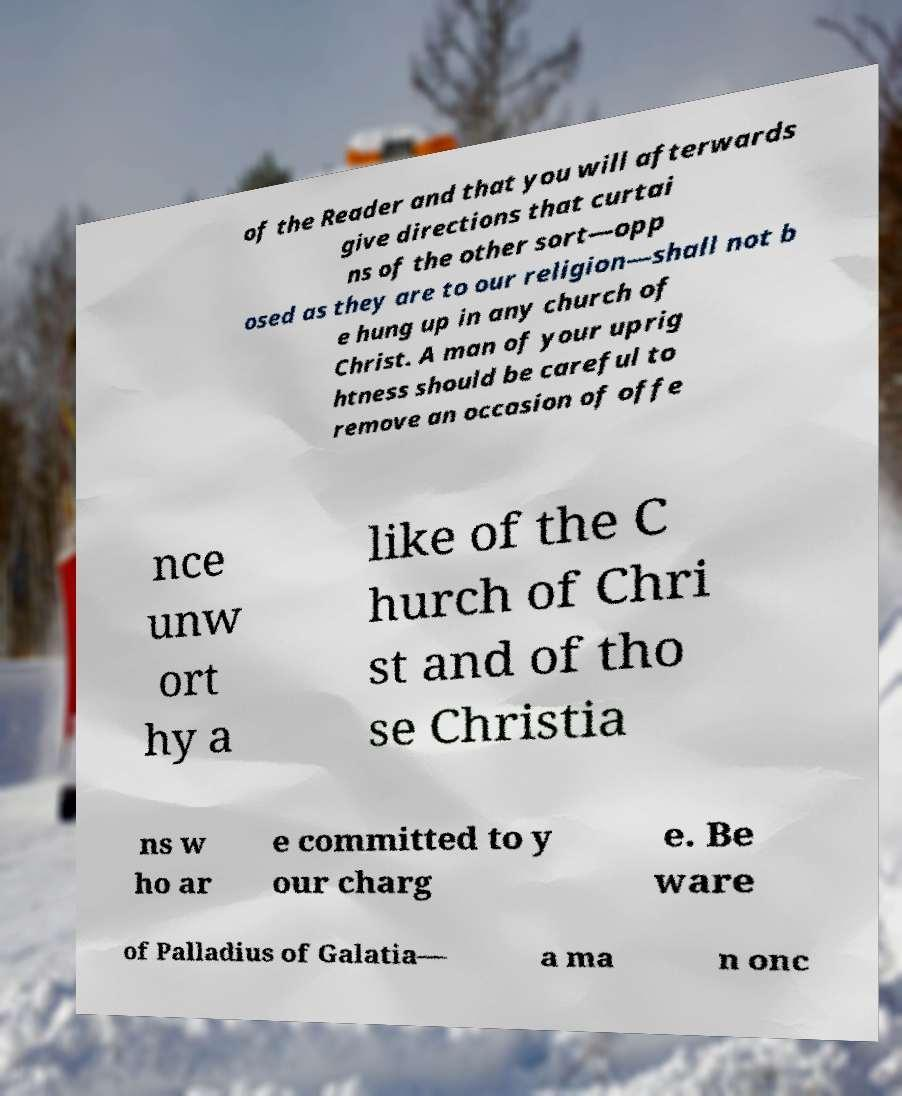I need the written content from this picture converted into text. Can you do that? of the Reader and that you will afterwards give directions that curtai ns of the other sort—opp osed as they are to our religion—shall not b e hung up in any church of Christ. A man of your uprig htness should be careful to remove an occasion of offe nce unw ort hy a like of the C hurch of Chri st and of tho se Christia ns w ho ar e committed to y our charg e. Be ware of Palladius of Galatia— a ma n onc 